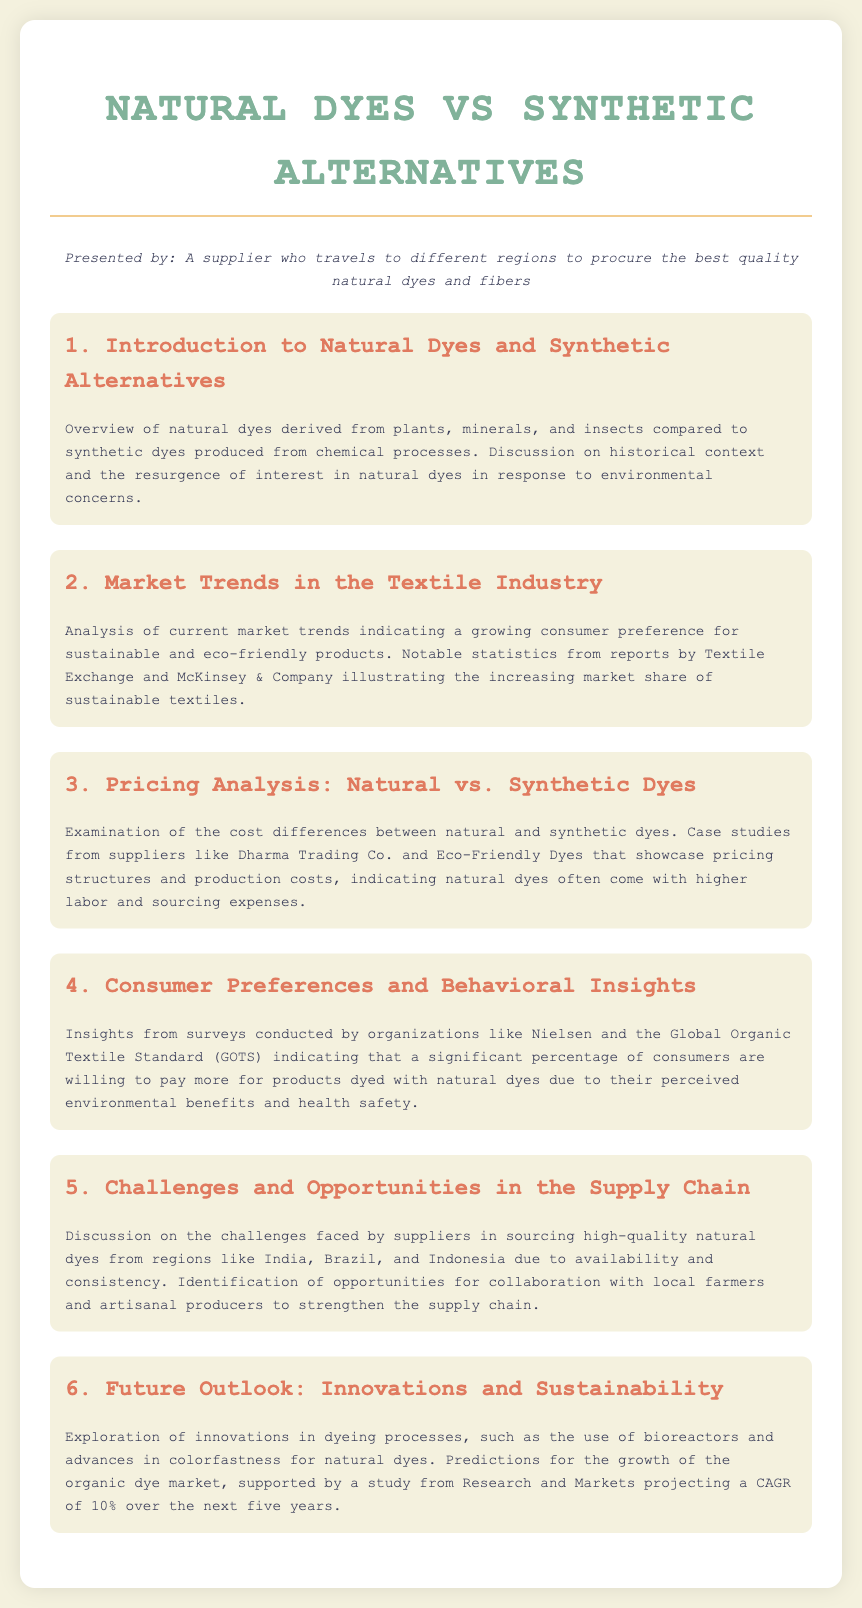What is the title of the document? The title of the document can be found in the header section and it is "Natural Dyes vs Synthetic Alternatives: A Comparative Analysis".
Answer: Natural Dyes vs Synthetic Alternatives: A Comparative Analysis Who presented the agenda? The persona section of the document specifies the presenter as "A supplier who travels to different regions to procure the best quality natural dyes and fibers".
Answer: A supplier who travels to different regions to procure the best quality natural dyes and fibers What percentage of consumers are willing to pay more for natural dyes? Insights from surveys in the document indicate that "a significant percentage of consumers" are willing to pay more for natural dyes due to perceived benefits, but it does not specify an exact number.
Answer: Significant percentage What year is the projected CAGR for the organic dye market? The document states that there is a projection for growth over "the next five years." Assuming the current year is 2023, this implies the projection is until 2028.
Answer: 2028 Which organizations provided surveys mentioned in the document? The document references "Nielsen" and "the Global Organic Textile Standard (GOTS)" as organizations that conducted consumer surveys.
Answer: Nielsen and GOTS What challenges do suppliers face according to the agenda? The agenda mentions "availability and consistency" as challenges faced by suppliers in sourcing high-quality natural dyes.
Answer: Availability and consistency What market trend is highlighted in the document? The document discusses a growing consumer preference for "sustainable and eco-friendly products" as a key market trend in the textile industry.
Answer: Sustainable and eco-friendly products What is the color of the heading "Future Outlook: Innovations and Sustainability"? The document indicates that the color for the heading is a shade of blue as part of the styling.
Answer: Blue 